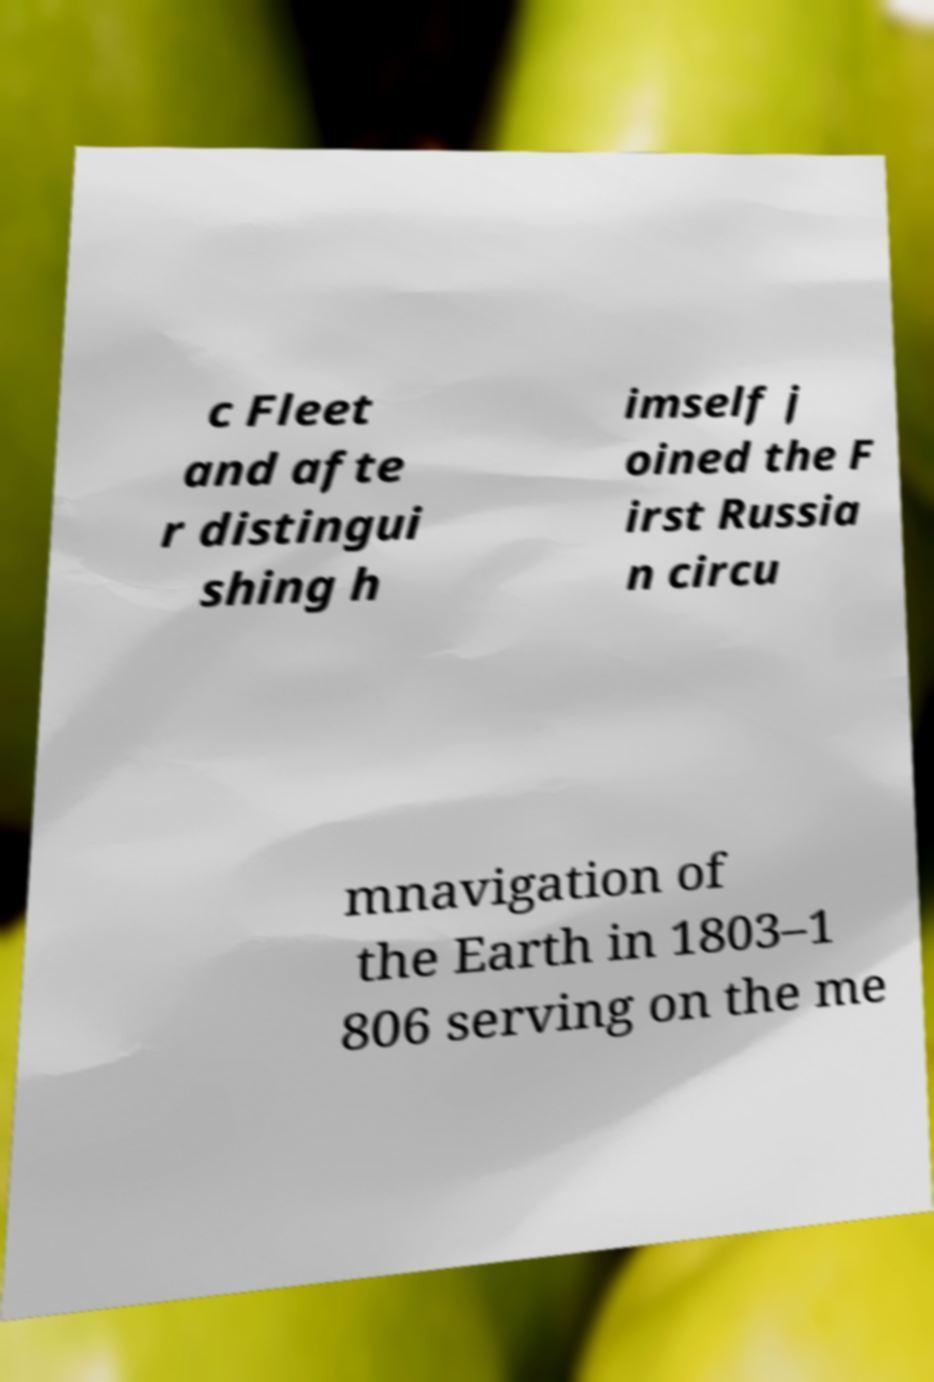Can you read and provide the text displayed in the image?This photo seems to have some interesting text. Can you extract and type it out for me? c Fleet and afte r distingui shing h imself j oined the F irst Russia n circu mnavigation of the Earth in 1803–1 806 serving on the me 